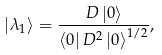<formula> <loc_0><loc_0><loc_500><loc_500>\left | \lambda _ { 1 } \right \rangle = \frac { D \left | 0 \right \rangle } { \left \langle 0 \right | D ^ { 2 } \left | 0 \right \rangle ^ { 1 / 2 } } ,</formula> 